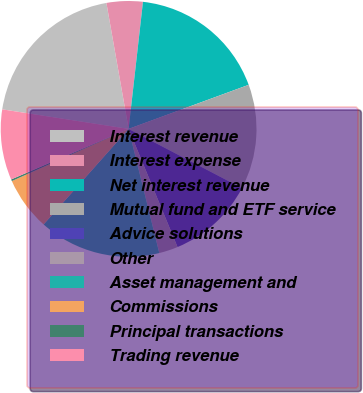Convert chart to OTSL. <chart><loc_0><loc_0><loc_500><loc_500><pie_chart><fcel>Interest revenue<fcel>Interest expense<fcel>Net interest revenue<fcel>Mutual fund and ETF service<fcel>Advice solutions<fcel>Other<fcel>Asset management and<fcel>Commissions<fcel>Principal transactions<fcel>Trading revenue<nl><fcel>19.78%<fcel>4.57%<fcel>17.61%<fcel>13.26%<fcel>11.09%<fcel>2.39%<fcel>15.43%<fcel>6.74%<fcel>0.22%<fcel>8.91%<nl></chart> 